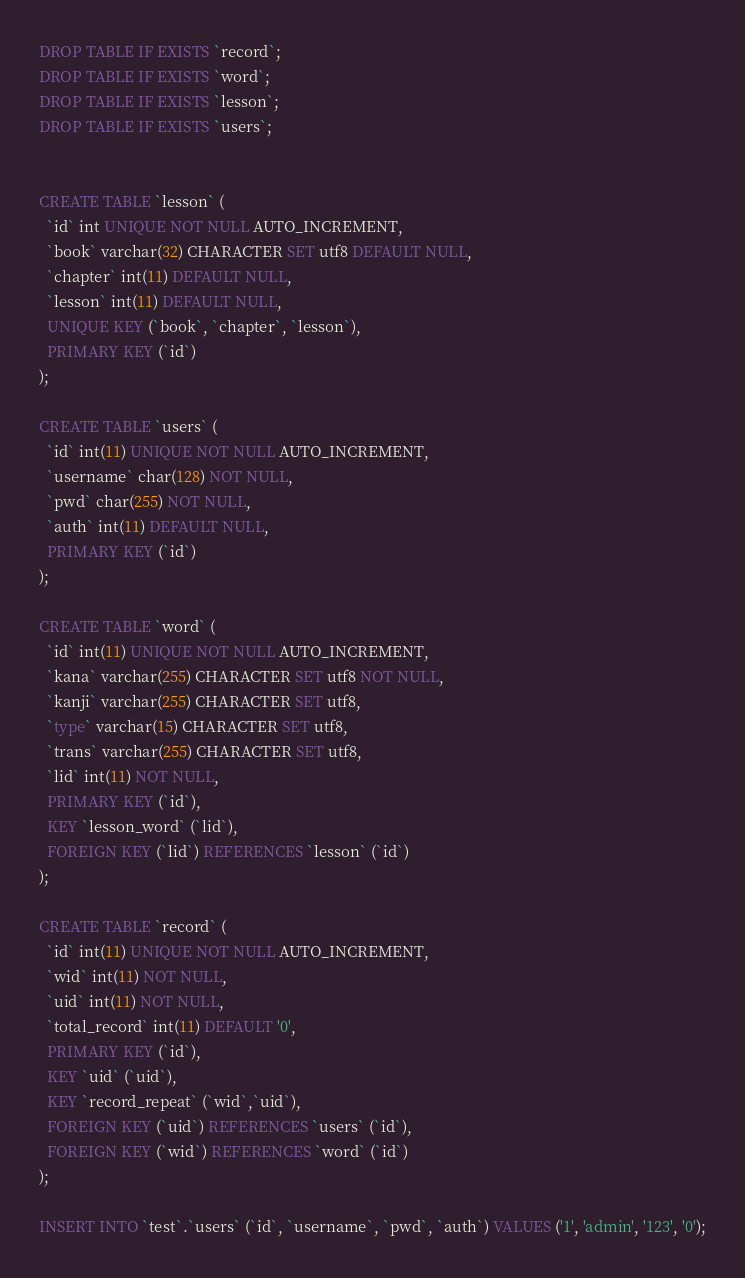Convert code to text. <code><loc_0><loc_0><loc_500><loc_500><_SQL_>DROP TABLE IF EXISTS `record`;
DROP TABLE IF EXISTS `word`;
DROP TABLE IF EXISTS `lesson`;
DROP TABLE IF EXISTS `users`;


CREATE TABLE `lesson` (
  `id` int UNIQUE NOT NULL AUTO_INCREMENT,
  `book` varchar(32) CHARACTER SET utf8 DEFAULT NULL,
  `chapter` int(11) DEFAULT NULL,
  `lesson` int(11) DEFAULT NULL,
  UNIQUE KEY (`book`, `chapter`, `lesson`),
  PRIMARY KEY (`id`)
);

CREATE TABLE `users` (
  `id` int(11) UNIQUE NOT NULL AUTO_INCREMENT,
  `username` char(128) NOT NULL,
  `pwd` char(255) NOT NULL,
  `auth` int(11) DEFAULT NULL,
  PRIMARY KEY (`id`)
);

CREATE TABLE `word` (
  `id` int(11) UNIQUE NOT NULL AUTO_INCREMENT,
  `kana` varchar(255) CHARACTER SET utf8 NOT NULL,
  `kanji` varchar(255) CHARACTER SET utf8,
  `type` varchar(15) CHARACTER SET utf8,
  `trans` varchar(255) CHARACTER SET utf8,
  `lid` int(11) NOT NULL,
  PRIMARY KEY (`id`),
  KEY `lesson_word` (`lid`),
  FOREIGN KEY (`lid`) REFERENCES `lesson` (`id`)
);

CREATE TABLE `record` (
  `id` int(11) UNIQUE NOT NULL AUTO_INCREMENT,
  `wid` int(11) NOT NULL,
  `uid` int(11) NOT NULL,
  `total_record` int(11) DEFAULT '0',
  PRIMARY KEY (`id`),
  KEY `uid` (`uid`),
  KEY `record_repeat` (`wid`,`uid`),
  FOREIGN KEY (`uid`) REFERENCES `users` (`id`),
  FOREIGN KEY (`wid`) REFERENCES `word` (`id`)
);

INSERT INTO `test`.`users` (`id`, `username`, `pwd`, `auth`) VALUES ('1', 'admin', '123', '0');</code> 